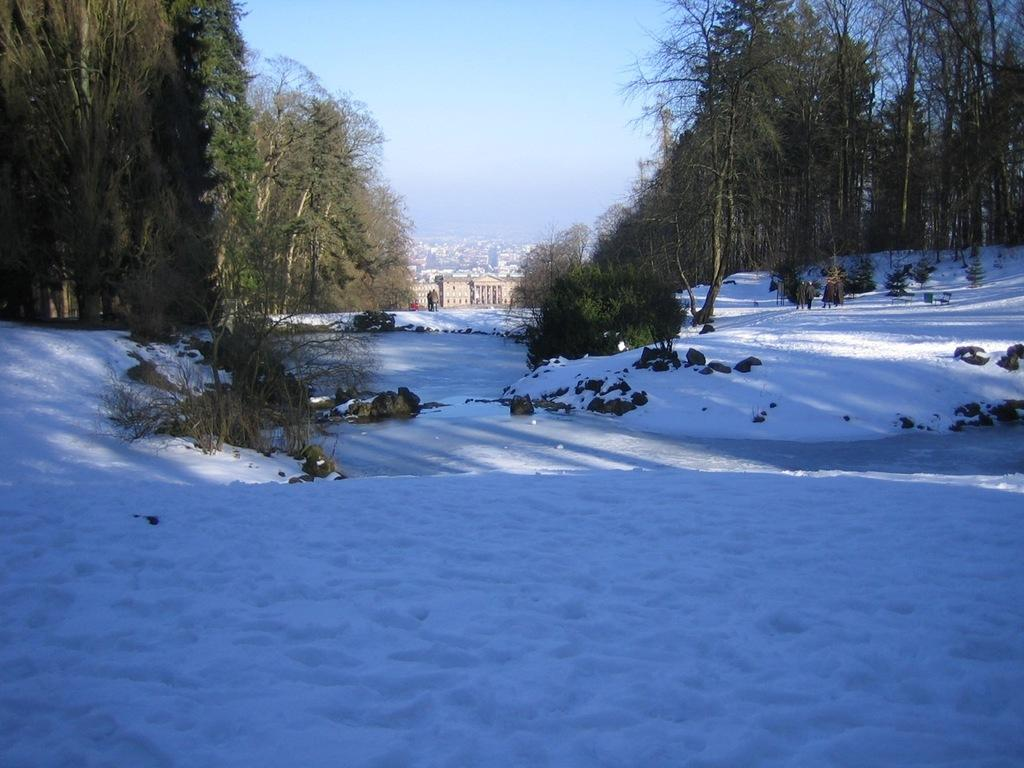What type of weather is depicted in the image? There is snow on the land in the image, indicating a winter scene. What can be seen in the middle of the image? There are trees in the middle of the image. What is visible at the top of the image? The sky is visible at the top of the image. What type of structures can be seen in the background of the image? There are buildings in the background of the image. Can you see a jellyfish swimming in the snow in the image? There is no jellyfish present in the image, and jellyfish cannot swim in snow. Where is the grandmother located in the image? There is no grandmother present in the image. 